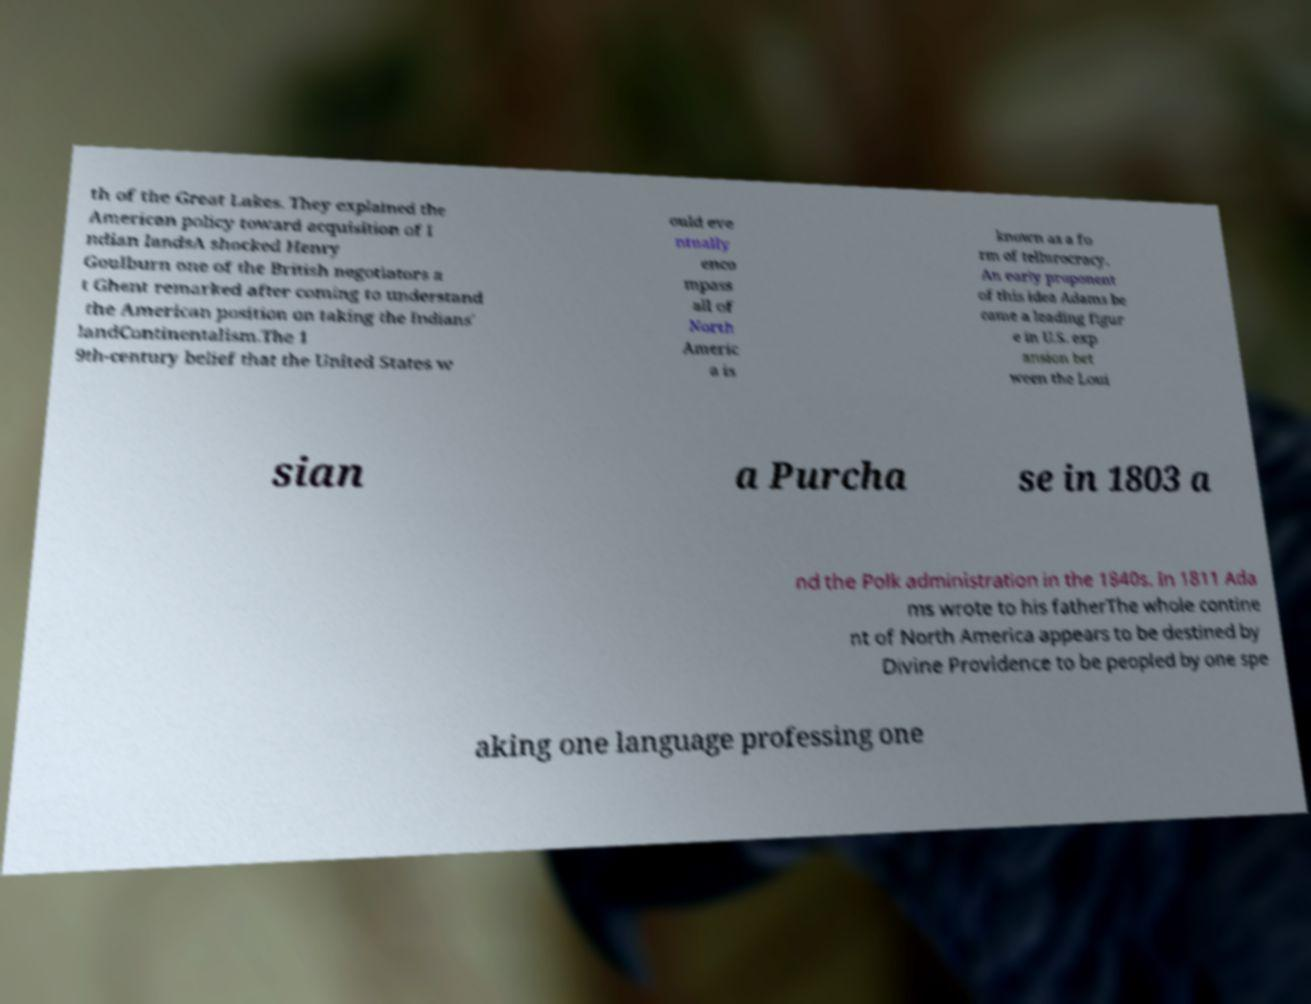Can you accurately transcribe the text from the provided image for me? th of the Great Lakes. They explained the American policy toward acquisition of I ndian landsA shocked Henry Goulburn one of the British negotiators a t Ghent remarked after coming to understand the American position on taking the Indians' landContinentalism.The 1 9th-century belief that the United States w ould eve ntually enco mpass all of North Americ a is known as a fo rm of tellurocracy. An early proponent of this idea Adams be came a leading figur e in U.S. exp ansion bet ween the Loui sian a Purcha se in 1803 a nd the Polk administration in the 1840s. In 1811 Ada ms wrote to his fatherThe whole contine nt of North America appears to be destined by Divine Providence to be peopled by one spe aking one language professing one 